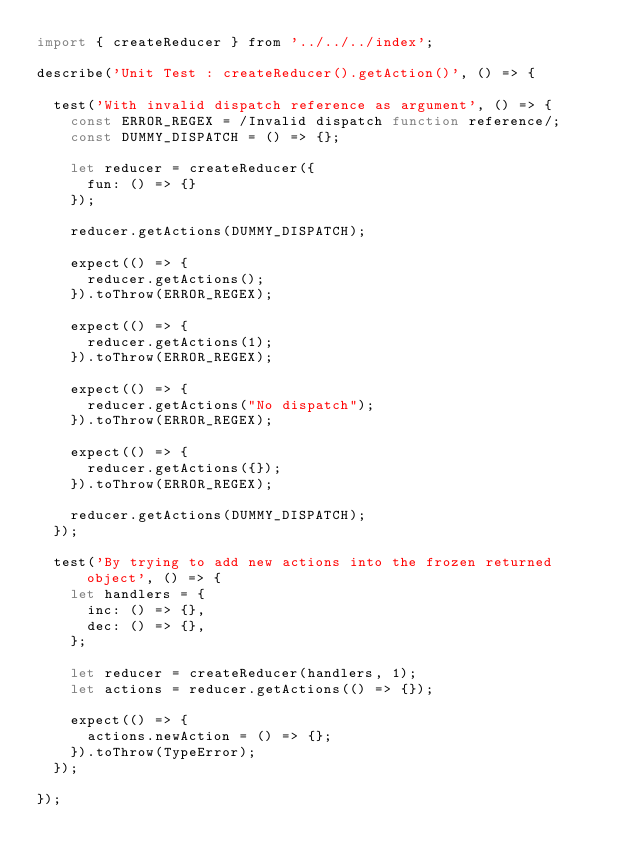<code> <loc_0><loc_0><loc_500><loc_500><_JavaScript_>import { createReducer } from '../../../index';

describe('Unit Test : createReducer().getAction()', () => {

  test('With invalid dispatch reference as argument', () => {
    const ERROR_REGEX = /Invalid dispatch function reference/;
    const DUMMY_DISPATCH = () => {};
  
    let reducer = createReducer({
      fun: () => {}
    });
  
    reducer.getActions(DUMMY_DISPATCH);
  
    expect(() => {
      reducer.getActions();
    }).toThrow(ERROR_REGEX);
  
    expect(() => {
      reducer.getActions(1);
    }).toThrow(ERROR_REGEX);
  
    expect(() => {
      reducer.getActions("No dispatch");
    }).toThrow(ERROR_REGEX);
  
    expect(() => {
      reducer.getActions({});
    }).toThrow(ERROR_REGEX);
  
    reducer.getActions(DUMMY_DISPATCH);
  });

  test('By trying to add new actions into the frozen returned object', () => {
    let handlers = {
      inc: () => {},
      dec: () => {},
    };
  
    let reducer = createReducer(handlers, 1);
    let actions = reducer.getActions(() => {});
  
    expect(() => {
      actions.newAction = () => {};
    }).toThrow(TypeError);
  });

});</code> 